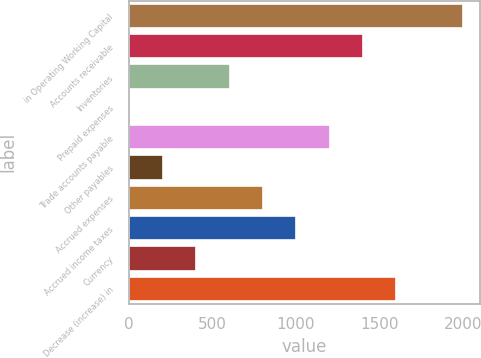Convert chart to OTSL. <chart><loc_0><loc_0><loc_500><loc_500><bar_chart><fcel>in Operating Working Capital<fcel>Accounts receivable<fcel>Inventories<fcel>Prepaid expenses<fcel>Trade accounts payable<fcel>Other payables<fcel>Accrued expenses<fcel>Accrued income taxes<fcel>Currency<fcel>Decrease (increase) in<nl><fcel>2001<fcel>1402.77<fcel>605.13<fcel>6.9<fcel>1203.36<fcel>206.31<fcel>804.54<fcel>1003.95<fcel>405.72<fcel>1602.18<nl></chart> 